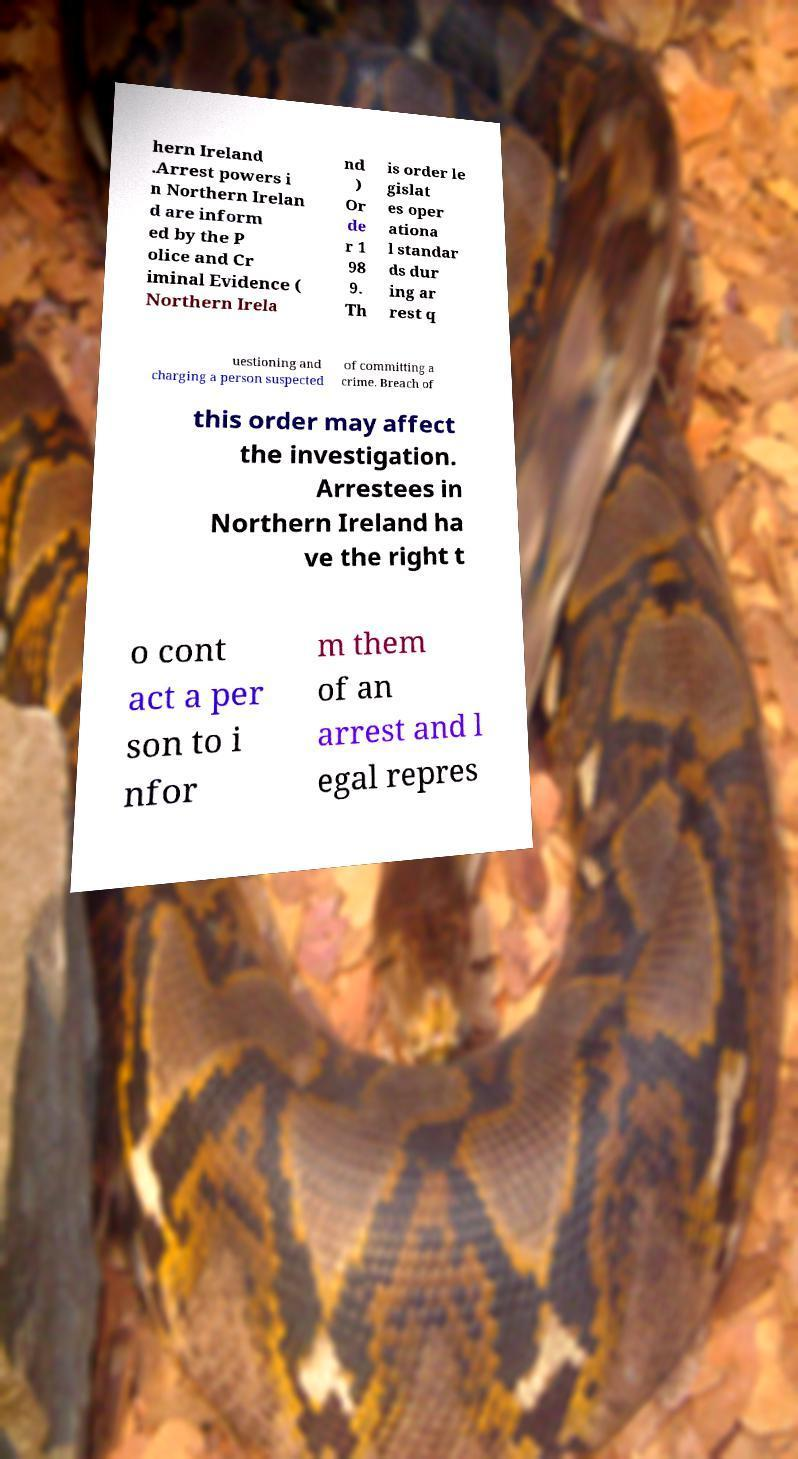There's text embedded in this image that I need extracted. Can you transcribe it verbatim? hern Ireland .Arrest powers i n Northern Irelan d are inform ed by the P olice and Cr iminal Evidence ( Northern Irela nd ) Or de r 1 98 9. Th is order le gislat es oper ationa l standar ds dur ing ar rest q uestioning and charging a person suspected of committing a crime. Breach of this order may affect the investigation. Arrestees in Northern Ireland ha ve the right t o cont act a per son to i nfor m them of an arrest and l egal repres 